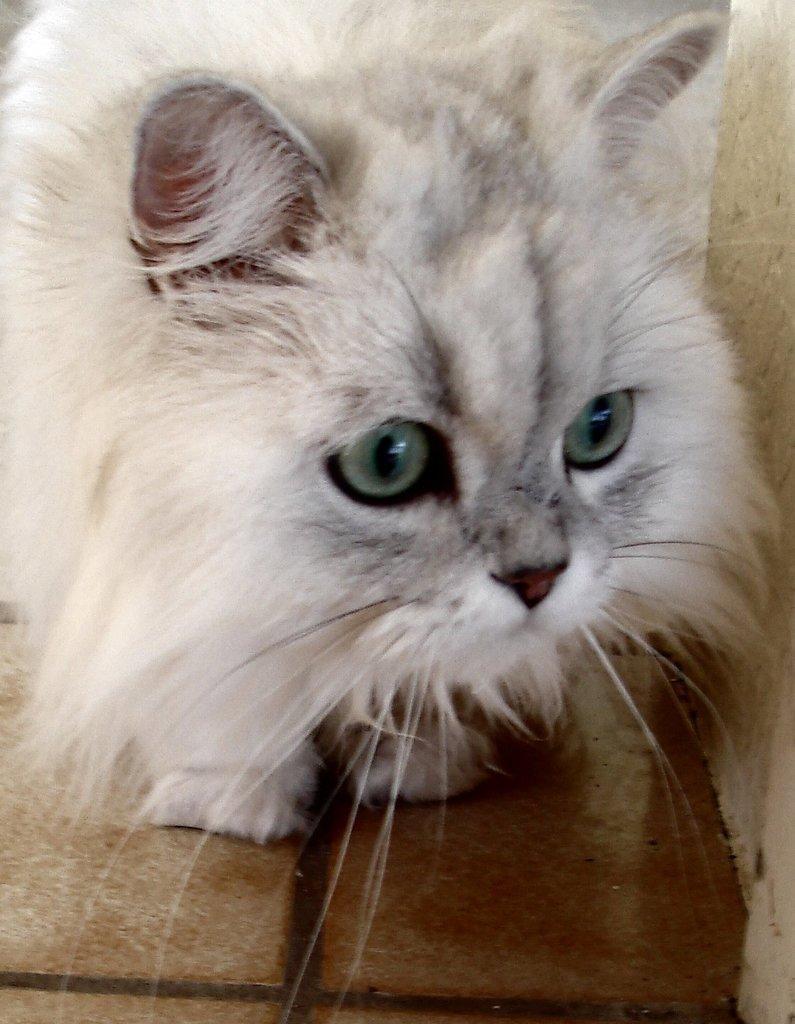Can you describe this image briefly? This picture shows a white color cat. 